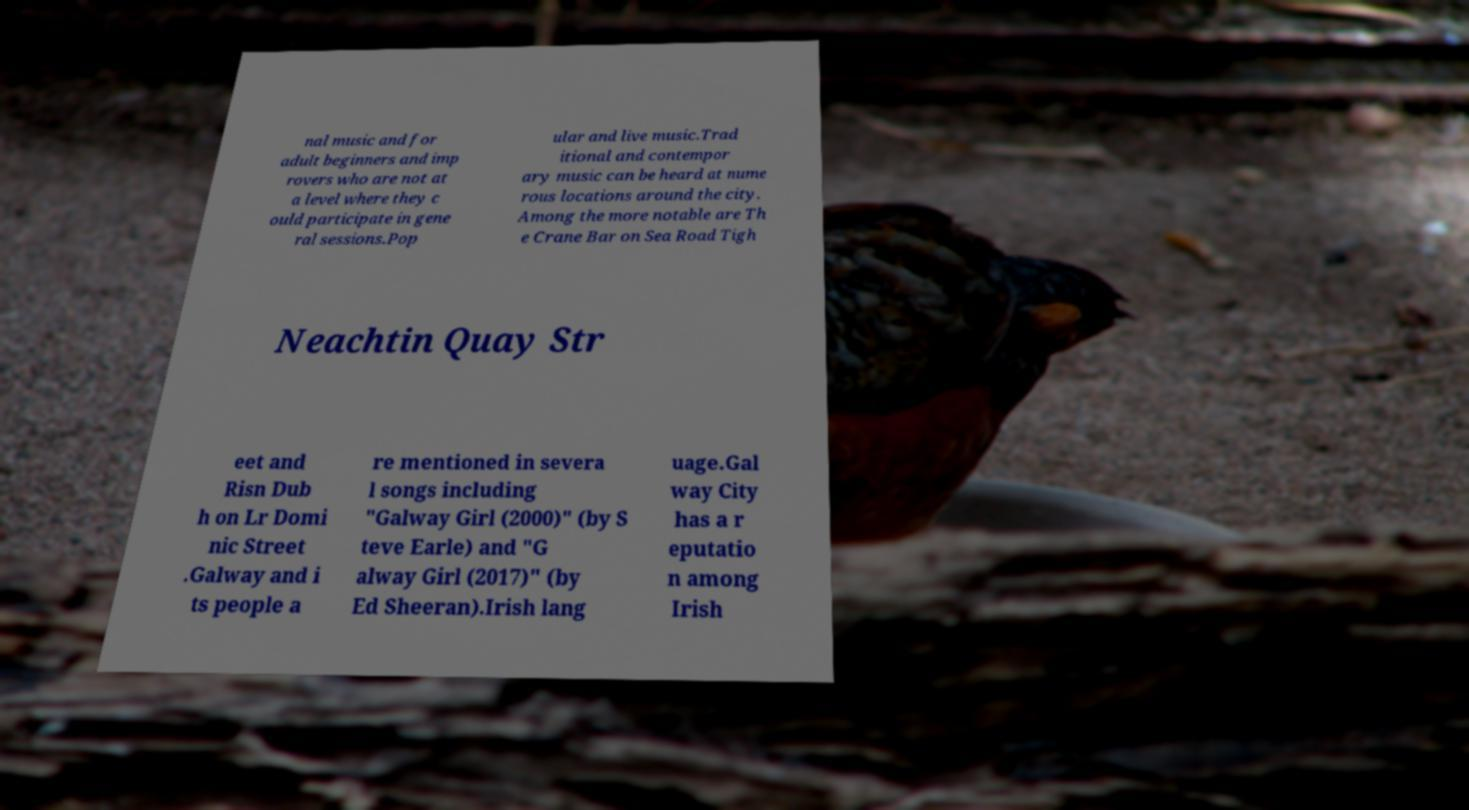Please identify and transcribe the text found in this image. nal music and for adult beginners and imp rovers who are not at a level where they c ould participate in gene ral sessions.Pop ular and live music.Trad itional and contempor ary music can be heard at nume rous locations around the city. Among the more notable are Th e Crane Bar on Sea Road Tigh Neachtin Quay Str eet and Risn Dub h on Lr Domi nic Street .Galway and i ts people a re mentioned in severa l songs including "Galway Girl (2000)" (by S teve Earle) and "G alway Girl (2017)" (by Ed Sheeran).Irish lang uage.Gal way City has a r eputatio n among Irish 